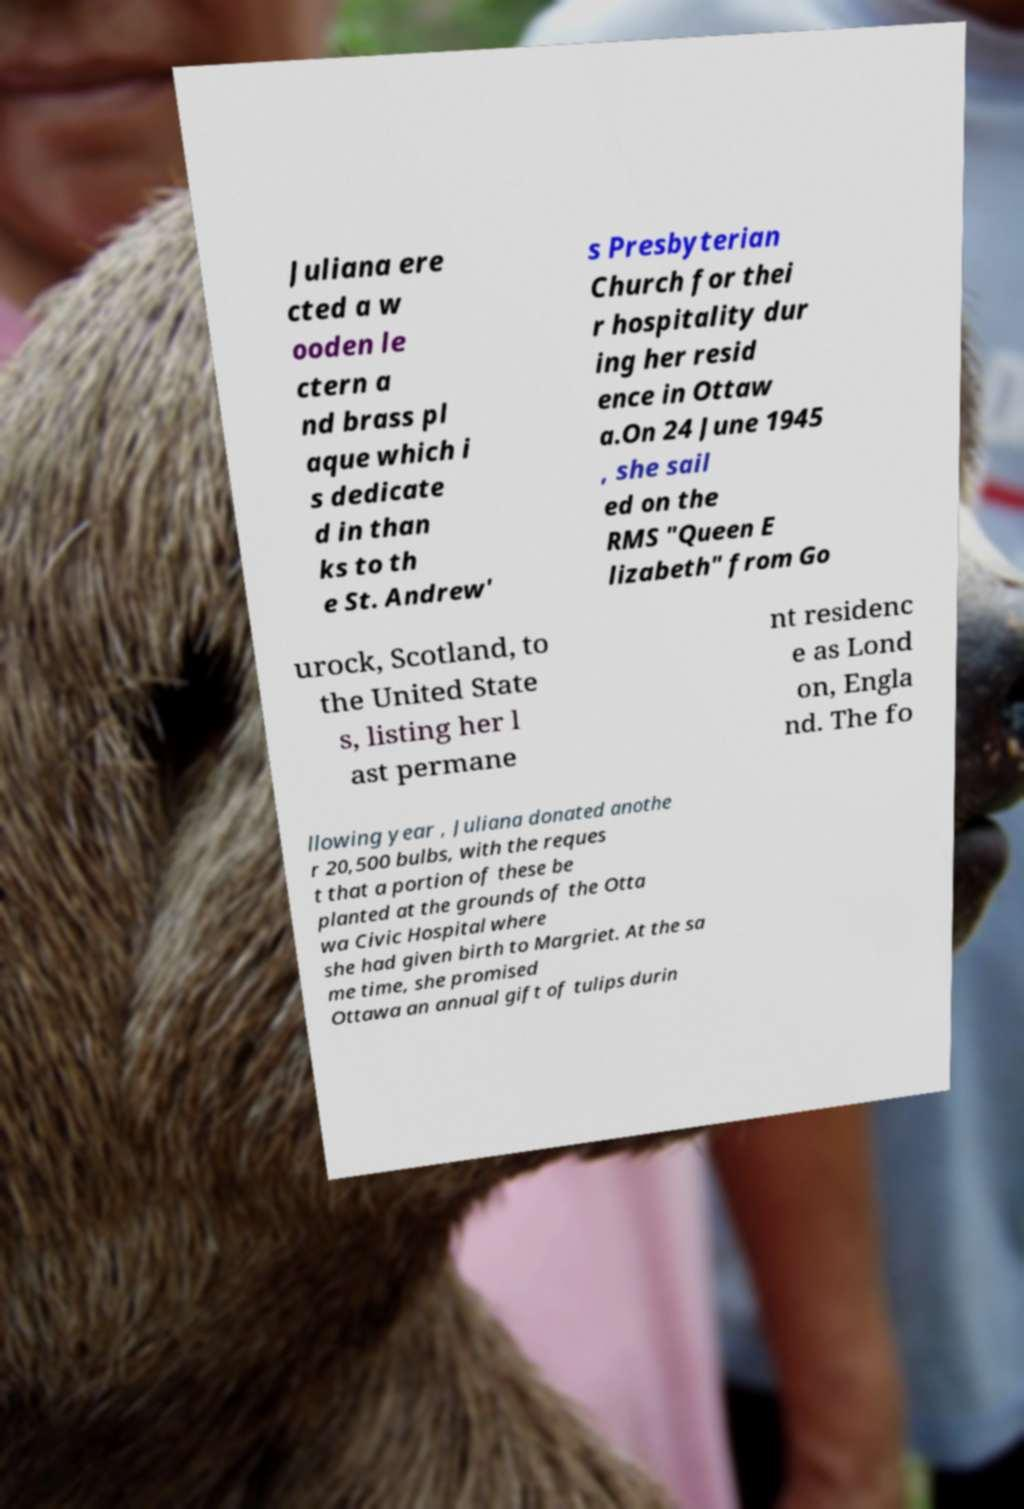For documentation purposes, I need the text within this image transcribed. Could you provide that? Juliana ere cted a w ooden le ctern a nd brass pl aque which i s dedicate d in than ks to th e St. Andrew' s Presbyterian Church for thei r hospitality dur ing her resid ence in Ottaw a.On 24 June 1945 , she sail ed on the RMS "Queen E lizabeth" from Go urock, Scotland, to the United State s, listing her l ast permane nt residenc e as Lond on, Engla nd. The fo llowing year , Juliana donated anothe r 20,500 bulbs, with the reques t that a portion of these be planted at the grounds of the Otta wa Civic Hospital where she had given birth to Margriet. At the sa me time, she promised Ottawa an annual gift of tulips durin 